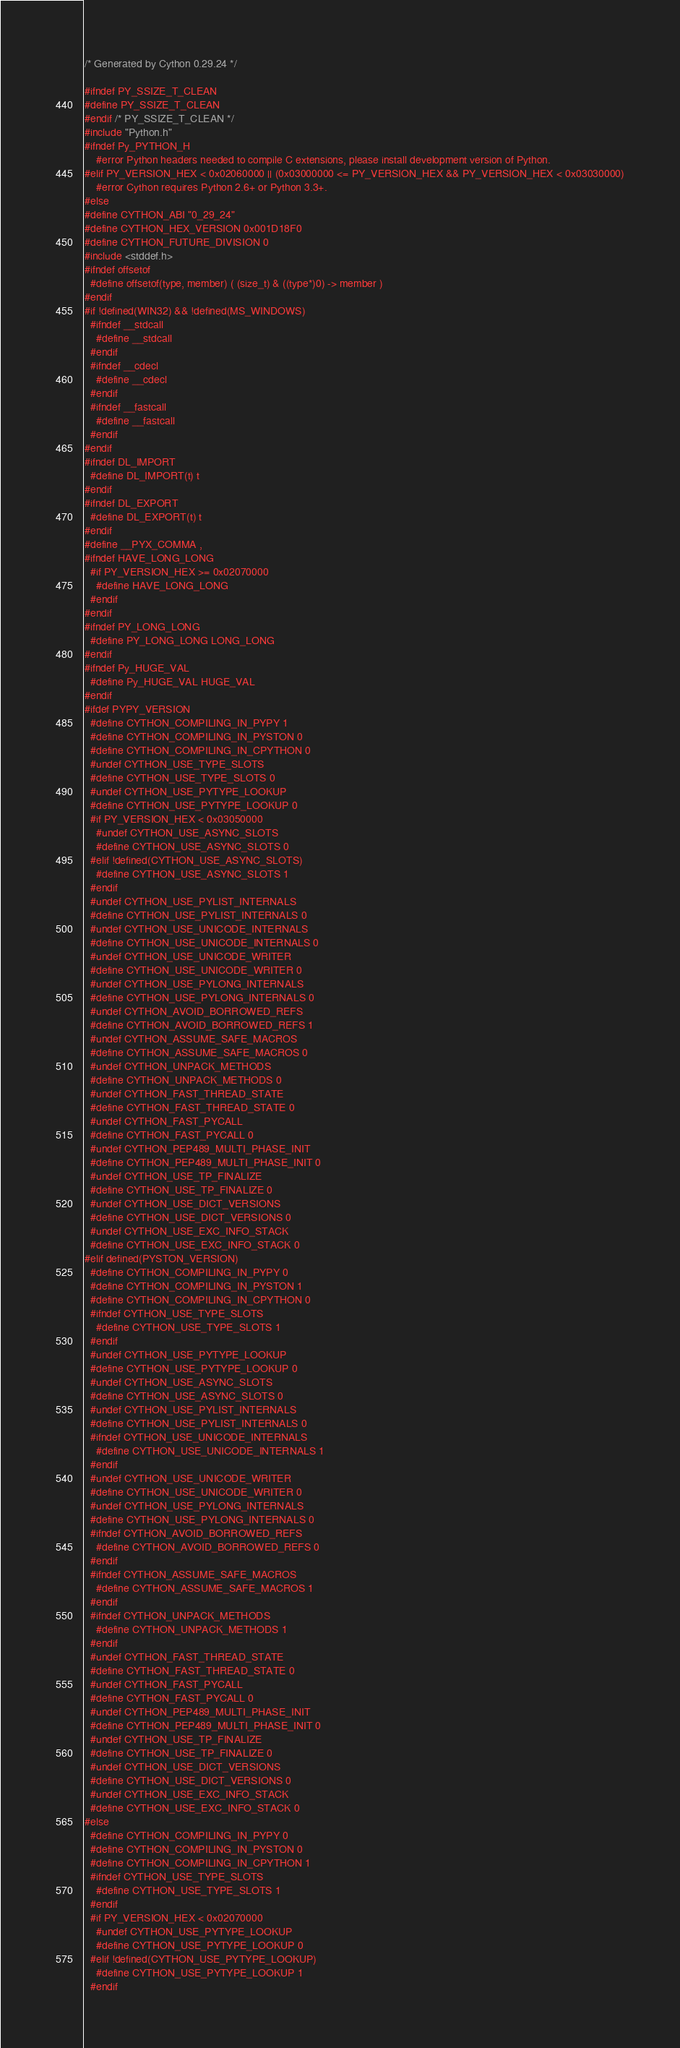<code> <loc_0><loc_0><loc_500><loc_500><_C_>/* Generated by Cython 0.29.24 */

#ifndef PY_SSIZE_T_CLEAN
#define PY_SSIZE_T_CLEAN
#endif /* PY_SSIZE_T_CLEAN */
#include "Python.h"
#ifndef Py_PYTHON_H
    #error Python headers needed to compile C extensions, please install development version of Python.
#elif PY_VERSION_HEX < 0x02060000 || (0x03000000 <= PY_VERSION_HEX && PY_VERSION_HEX < 0x03030000)
    #error Cython requires Python 2.6+ or Python 3.3+.
#else
#define CYTHON_ABI "0_29_24"
#define CYTHON_HEX_VERSION 0x001D18F0
#define CYTHON_FUTURE_DIVISION 0
#include <stddef.h>
#ifndef offsetof
  #define offsetof(type, member) ( (size_t) & ((type*)0) -> member )
#endif
#if !defined(WIN32) && !defined(MS_WINDOWS)
  #ifndef __stdcall
    #define __stdcall
  #endif
  #ifndef __cdecl
    #define __cdecl
  #endif
  #ifndef __fastcall
    #define __fastcall
  #endif
#endif
#ifndef DL_IMPORT
  #define DL_IMPORT(t) t
#endif
#ifndef DL_EXPORT
  #define DL_EXPORT(t) t
#endif
#define __PYX_COMMA ,
#ifndef HAVE_LONG_LONG
  #if PY_VERSION_HEX >= 0x02070000
    #define HAVE_LONG_LONG
  #endif
#endif
#ifndef PY_LONG_LONG
  #define PY_LONG_LONG LONG_LONG
#endif
#ifndef Py_HUGE_VAL
  #define Py_HUGE_VAL HUGE_VAL
#endif
#ifdef PYPY_VERSION
  #define CYTHON_COMPILING_IN_PYPY 1
  #define CYTHON_COMPILING_IN_PYSTON 0
  #define CYTHON_COMPILING_IN_CPYTHON 0
  #undef CYTHON_USE_TYPE_SLOTS
  #define CYTHON_USE_TYPE_SLOTS 0
  #undef CYTHON_USE_PYTYPE_LOOKUP
  #define CYTHON_USE_PYTYPE_LOOKUP 0
  #if PY_VERSION_HEX < 0x03050000
    #undef CYTHON_USE_ASYNC_SLOTS
    #define CYTHON_USE_ASYNC_SLOTS 0
  #elif !defined(CYTHON_USE_ASYNC_SLOTS)
    #define CYTHON_USE_ASYNC_SLOTS 1
  #endif
  #undef CYTHON_USE_PYLIST_INTERNALS
  #define CYTHON_USE_PYLIST_INTERNALS 0
  #undef CYTHON_USE_UNICODE_INTERNALS
  #define CYTHON_USE_UNICODE_INTERNALS 0
  #undef CYTHON_USE_UNICODE_WRITER
  #define CYTHON_USE_UNICODE_WRITER 0
  #undef CYTHON_USE_PYLONG_INTERNALS
  #define CYTHON_USE_PYLONG_INTERNALS 0
  #undef CYTHON_AVOID_BORROWED_REFS
  #define CYTHON_AVOID_BORROWED_REFS 1
  #undef CYTHON_ASSUME_SAFE_MACROS
  #define CYTHON_ASSUME_SAFE_MACROS 0
  #undef CYTHON_UNPACK_METHODS
  #define CYTHON_UNPACK_METHODS 0
  #undef CYTHON_FAST_THREAD_STATE
  #define CYTHON_FAST_THREAD_STATE 0
  #undef CYTHON_FAST_PYCALL
  #define CYTHON_FAST_PYCALL 0
  #undef CYTHON_PEP489_MULTI_PHASE_INIT
  #define CYTHON_PEP489_MULTI_PHASE_INIT 0
  #undef CYTHON_USE_TP_FINALIZE
  #define CYTHON_USE_TP_FINALIZE 0
  #undef CYTHON_USE_DICT_VERSIONS
  #define CYTHON_USE_DICT_VERSIONS 0
  #undef CYTHON_USE_EXC_INFO_STACK
  #define CYTHON_USE_EXC_INFO_STACK 0
#elif defined(PYSTON_VERSION)
  #define CYTHON_COMPILING_IN_PYPY 0
  #define CYTHON_COMPILING_IN_PYSTON 1
  #define CYTHON_COMPILING_IN_CPYTHON 0
  #ifndef CYTHON_USE_TYPE_SLOTS
    #define CYTHON_USE_TYPE_SLOTS 1
  #endif
  #undef CYTHON_USE_PYTYPE_LOOKUP
  #define CYTHON_USE_PYTYPE_LOOKUP 0
  #undef CYTHON_USE_ASYNC_SLOTS
  #define CYTHON_USE_ASYNC_SLOTS 0
  #undef CYTHON_USE_PYLIST_INTERNALS
  #define CYTHON_USE_PYLIST_INTERNALS 0
  #ifndef CYTHON_USE_UNICODE_INTERNALS
    #define CYTHON_USE_UNICODE_INTERNALS 1
  #endif
  #undef CYTHON_USE_UNICODE_WRITER
  #define CYTHON_USE_UNICODE_WRITER 0
  #undef CYTHON_USE_PYLONG_INTERNALS
  #define CYTHON_USE_PYLONG_INTERNALS 0
  #ifndef CYTHON_AVOID_BORROWED_REFS
    #define CYTHON_AVOID_BORROWED_REFS 0
  #endif
  #ifndef CYTHON_ASSUME_SAFE_MACROS
    #define CYTHON_ASSUME_SAFE_MACROS 1
  #endif
  #ifndef CYTHON_UNPACK_METHODS
    #define CYTHON_UNPACK_METHODS 1
  #endif
  #undef CYTHON_FAST_THREAD_STATE
  #define CYTHON_FAST_THREAD_STATE 0
  #undef CYTHON_FAST_PYCALL
  #define CYTHON_FAST_PYCALL 0
  #undef CYTHON_PEP489_MULTI_PHASE_INIT
  #define CYTHON_PEP489_MULTI_PHASE_INIT 0
  #undef CYTHON_USE_TP_FINALIZE
  #define CYTHON_USE_TP_FINALIZE 0
  #undef CYTHON_USE_DICT_VERSIONS
  #define CYTHON_USE_DICT_VERSIONS 0
  #undef CYTHON_USE_EXC_INFO_STACK
  #define CYTHON_USE_EXC_INFO_STACK 0
#else
  #define CYTHON_COMPILING_IN_PYPY 0
  #define CYTHON_COMPILING_IN_PYSTON 0
  #define CYTHON_COMPILING_IN_CPYTHON 1
  #ifndef CYTHON_USE_TYPE_SLOTS
    #define CYTHON_USE_TYPE_SLOTS 1
  #endif
  #if PY_VERSION_HEX < 0x02070000
    #undef CYTHON_USE_PYTYPE_LOOKUP
    #define CYTHON_USE_PYTYPE_LOOKUP 0
  #elif !defined(CYTHON_USE_PYTYPE_LOOKUP)
    #define CYTHON_USE_PYTYPE_LOOKUP 1
  #endif</code> 